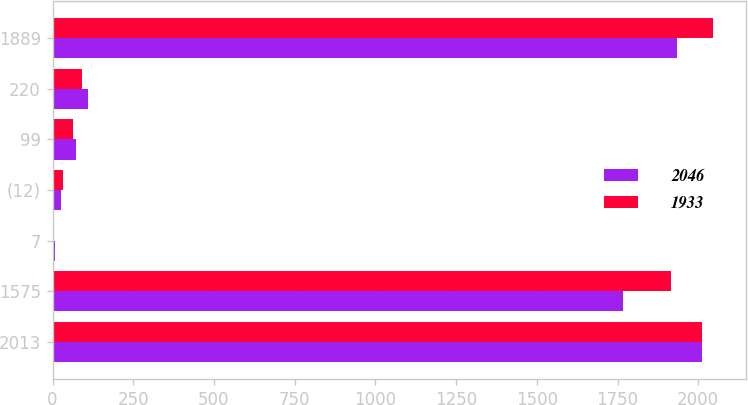Convert chart. <chart><loc_0><loc_0><loc_500><loc_500><stacked_bar_chart><ecel><fcel>2013<fcel>1575<fcel>7<fcel>(12)<fcel>99<fcel>220<fcel>1889<nl><fcel>2046<fcel>2012<fcel>1768<fcel>7<fcel>25<fcel>73<fcel>110<fcel>1933<nl><fcel>1933<fcel>2011<fcel>1917<fcel>6<fcel>32<fcel>64<fcel>91<fcel>2046<nl></chart> 